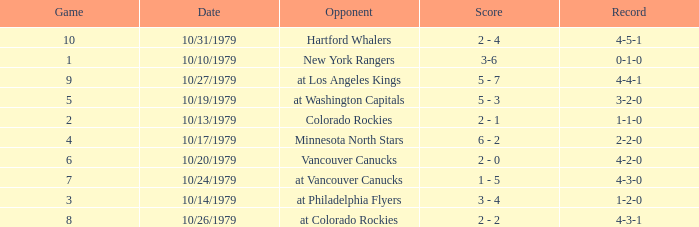What is the score for the opponent Vancouver Canucks? 2 - 0. 